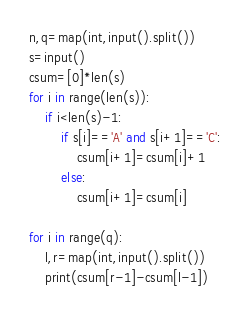Convert code to text. <code><loc_0><loc_0><loc_500><loc_500><_Python_>n,q=map(int,input().split())
s=input()
csum=[0]*len(s)
for i in range(len(s)):
    if i<len(s)-1:
        if s[i]=='A' and s[i+1]=='C':
            csum[i+1]=csum[i]+1
        else:
            csum[i+1]=csum[i]

for i in range(q):
    l,r=map(int,input().split())
    print(csum[r-1]-csum[l-1])</code> 